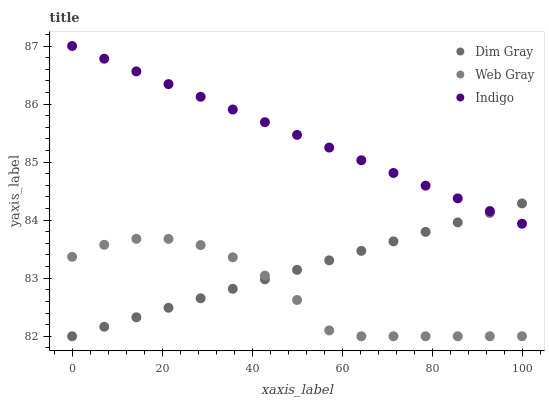Does Web Gray have the minimum area under the curve?
Answer yes or no. Yes. Does Indigo have the maximum area under the curve?
Answer yes or no. Yes. Does Dim Gray have the minimum area under the curve?
Answer yes or no. No. Does Dim Gray have the maximum area under the curve?
Answer yes or no. No. Is Indigo the smoothest?
Answer yes or no. Yes. Is Web Gray the roughest?
Answer yes or no. Yes. Is Dim Gray the smoothest?
Answer yes or no. No. Is Dim Gray the roughest?
Answer yes or no. No. Does Dim Gray have the lowest value?
Answer yes or no. Yes. Does Indigo have the highest value?
Answer yes or no. Yes. Does Dim Gray have the highest value?
Answer yes or no. No. Is Web Gray less than Indigo?
Answer yes or no. Yes. Is Indigo greater than Web Gray?
Answer yes or no. Yes. Does Dim Gray intersect Indigo?
Answer yes or no. Yes. Is Dim Gray less than Indigo?
Answer yes or no. No. Is Dim Gray greater than Indigo?
Answer yes or no. No. Does Web Gray intersect Indigo?
Answer yes or no. No. 